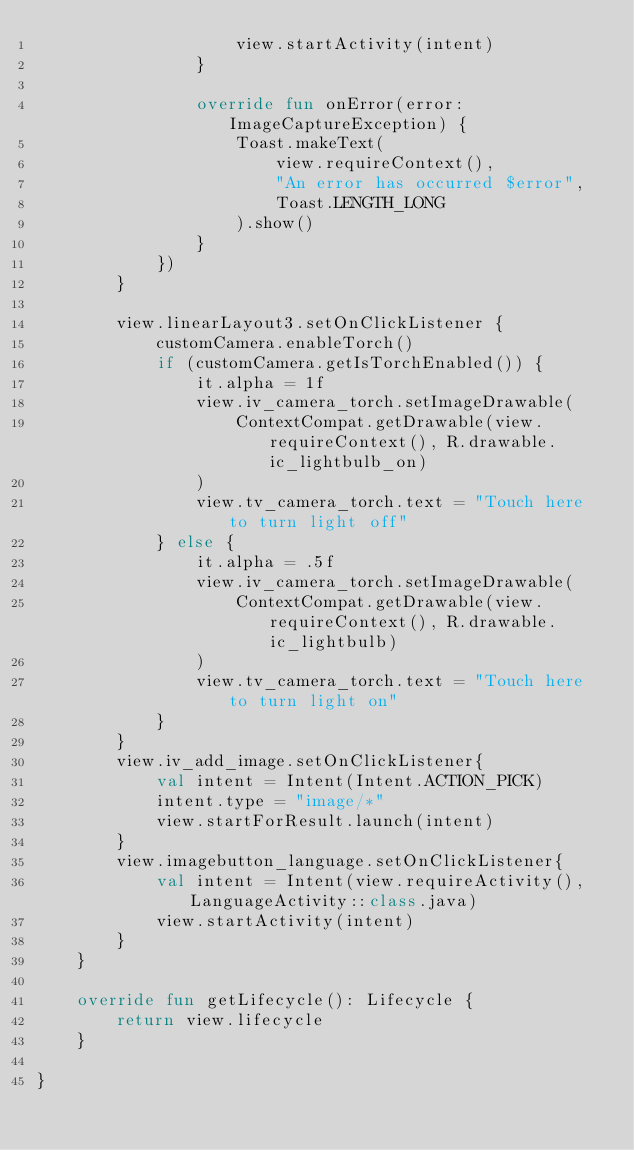<code> <loc_0><loc_0><loc_500><loc_500><_Kotlin_>                    view.startActivity(intent)
                }

                override fun onError(error: ImageCaptureException) {
                    Toast.makeText(
                        view.requireContext(),
                        "An error has occurred $error",
                        Toast.LENGTH_LONG
                    ).show()
                }
            })
        }

        view.linearLayout3.setOnClickListener {
            customCamera.enableTorch()
            if (customCamera.getIsTorchEnabled()) {
                it.alpha = 1f
                view.iv_camera_torch.setImageDrawable(
                    ContextCompat.getDrawable(view.requireContext(), R.drawable.ic_lightbulb_on)
                )
                view.tv_camera_torch.text = "Touch here to turn light off"
            } else {
                it.alpha = .5f
                view.iv_camera_torch.setImageDrawable(
                    ContextCompat.getDrawable(view.requireContext(), R.drawable.ic_lightbulb)
                )
                view.tv_camera_torch.text = "Touch here to turn light on"
            }
        }
        view.iv_add_image.setOnClickListener{
            val intent = Intent(Intent.ACTION_PICK)
            intent.type = "image/*"
            view.startForResult.launch(intent)
        }
        view.imagebutton_language.setOnClickListener{
            val intent = Intent(view.requireActivity(), LanguageActivity::class.java)
            view.startActivity(intent)
        }
    }

    override fun getLifecycle(): Lifecycle {
        return view.lifecycle
    }

}</code> 